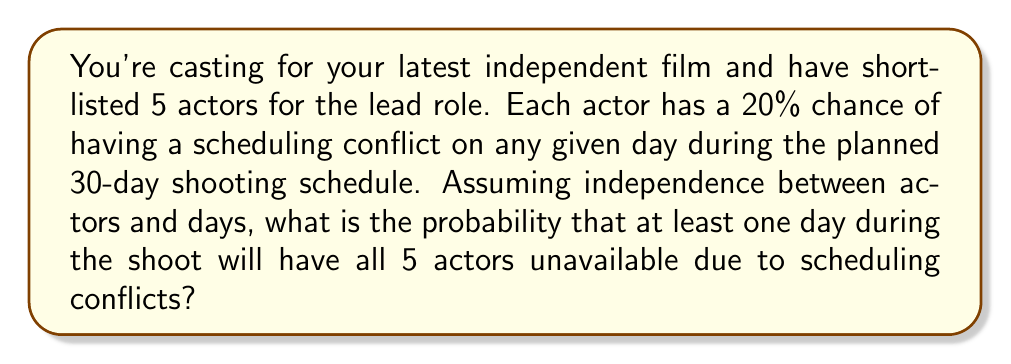Teach me how to tackle this problem. Let's approach this step-by-step:

1) First, let's calculate the probability of all 5 actors being available on a single day:
   $P(\text{all available}) = (1 - 0.2)^5 = 0.8^5 = 0.32768$

2) Therefore, the probability of at least one actor being unavailable on a single day is:
   $P(\text{at least one unavailable}) = 1 - 0.32768 = 0.67232$

3) The probability we're looking for is the opposite of having at least one actor available every day for 30 days. So, let's calculate the probability of having at least one actor available each day:
   $P(\text{at least one available each day}) = (1 - 0.67232)^{30}$

4) Now we can calculate the probability of having all actors unavailable on at least one day:
   $P(\text{all unavailable on at least one day}) = 1 - (1 - 0.67232)^{30}$

5) Let's compute this:
   $1 - (1 - 0.67232)^{30} = 1 - (0.32768)^{30} = 1 - 1.7147 \times 10^{-15} \approx 0.999999999999998$

Therefore, the probability is extremely close to 1, or 99.9999999999998%.
Answer: $$0.999999999999998$$ 